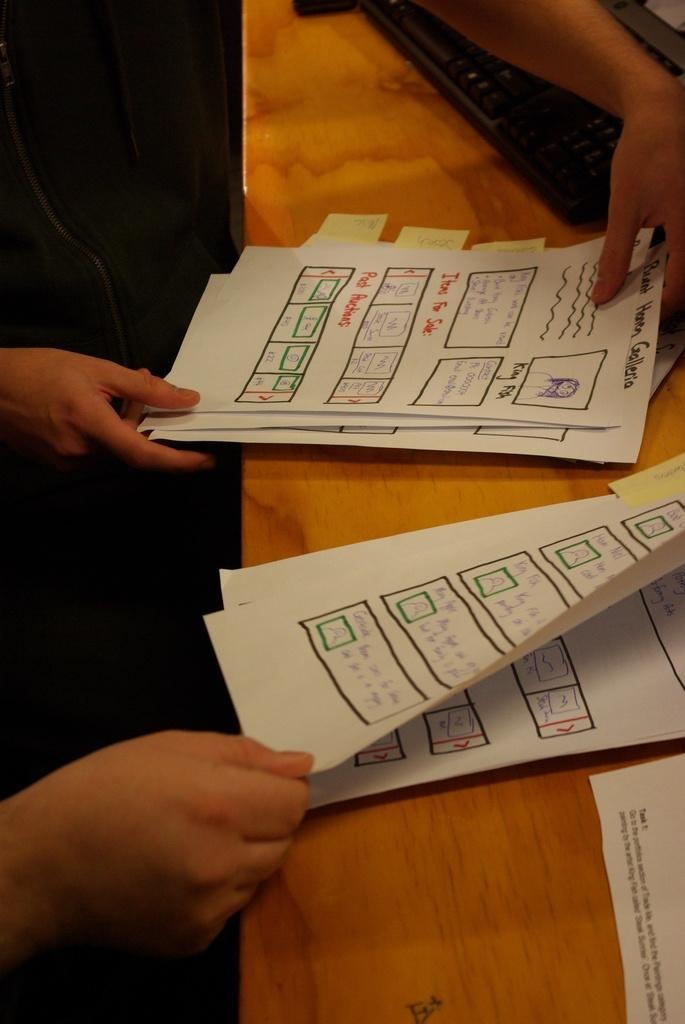What is on the desk in the image? There are papers on a brown color desk, and there is a black color keyboard on the desk. What is the color of the desk? The desk is brown in color. What is the color of the keyboard? The keyboard is black in color. Who might be holding the papers? Human hands are holding the papers. What type of fork is being used to type on the keyboard in the image? There is no fork present in the image; it features a black color keyboard and papers on a brown color desk. Who is the creator of the papers on the desk? The image does not provide information about the creator of the papers. 